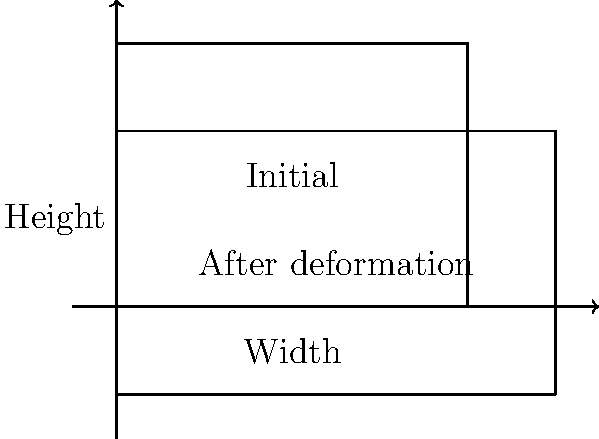A rectangular sample of a high-temperature alloy initially has a cross-sectional area of 12 cm². During a plastic deformation experiment at 1200°C, the sample's width increases by 25% while its height decreases by 20%. Calculate the new cross-sectional area of the sample after deformation. Assume the material's volume remains constant during the process. To solve this problem, we'll follow these steps:

1) Let's denote the initial dimensions:
   Width = $w$, Height = $h$
   Initial area $A_i = w \times h = 12$ cm²

2) After deformation:
   New width $w_n = w + 25\% = 1.25w$
   New height $h_n = h - 20\% = 0.8h$

3) The volume conservation principle states that:
   $V_i = V_f$, where $V_i$ is initial volume and $V_f$ is final volume

4) For a constant length $L$:
   $A_i \times L = A_f \times L$
   $A_i = A_f$

5) Therefore:
   $w \times h = w_n \times h_n$
   $w \times h = 1.25w \times 0.8h$

6) Simplify:
   $1 = 1.25 \times 0.8 = 1$

   This confirms that our calculations are consistent with volume conservation.

7) Now, to find the new area $A_f$:
   $A_f = w_n \times h_n = 1.25w \times 0.8h = w \times h$

8) We know that $w \times h = 12$ cm², so:
   $A_f = 12$ cm²

Thus, the cross-sectional area remains unchanged at 12 cm² after deformation.
Answer: 12 cm² 